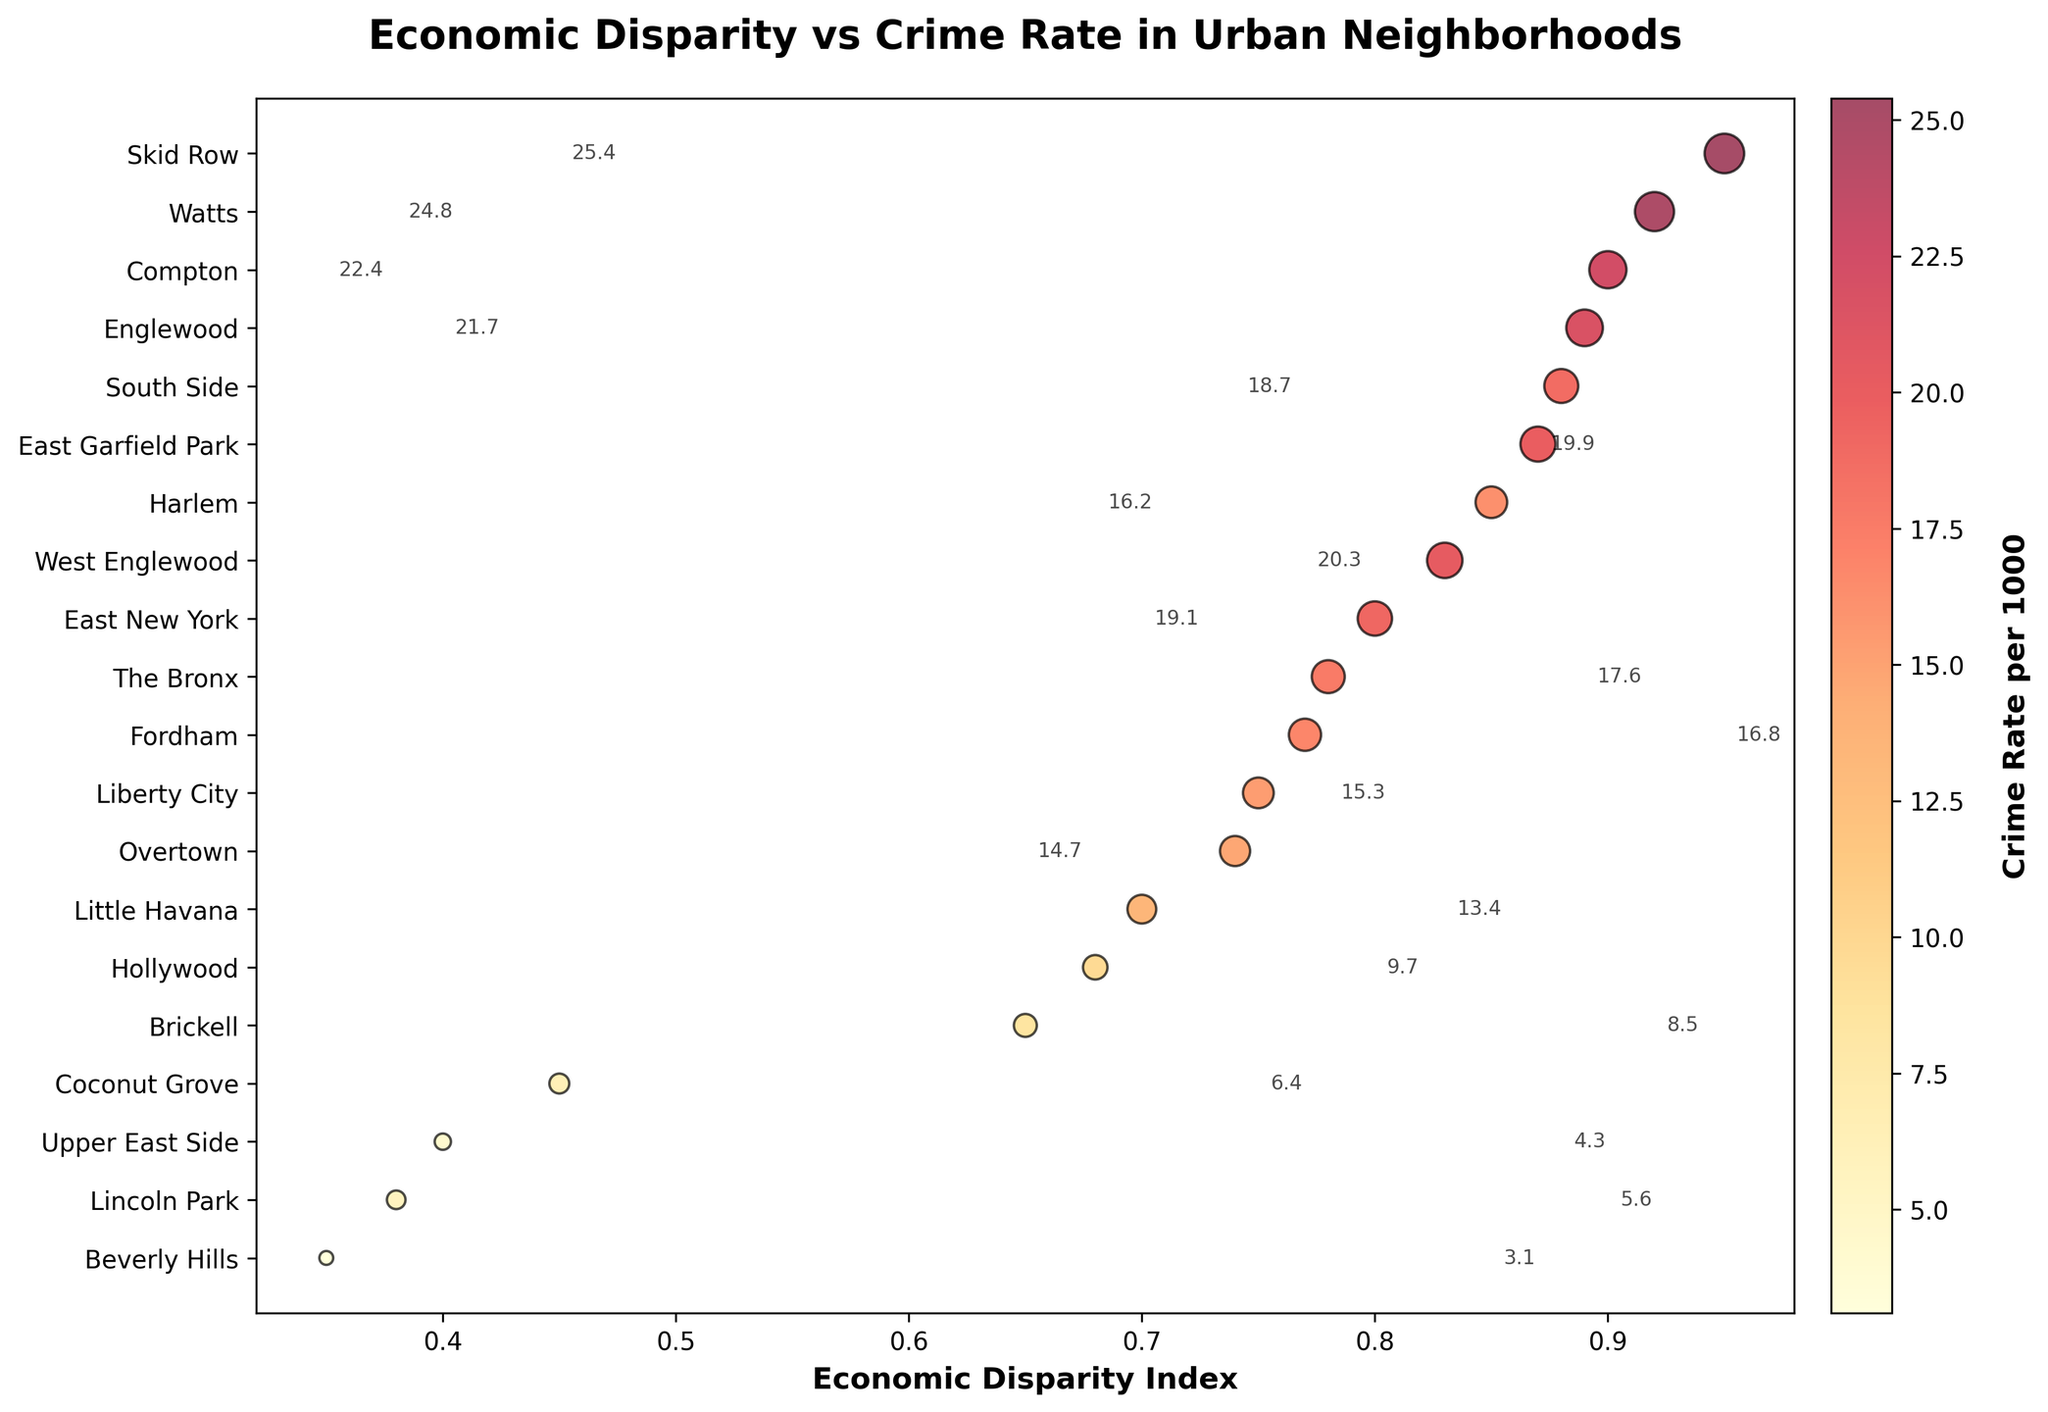What is the title of the plot? The title of the plot is displayed at the top of the figure. It reads "Economic Disparity vs Crime Rate in Urban Neighborhoods".
Answer: Economic Disparity vs Crime Rate in Urban Neighborhoods Which neighborhood has the highest economic disparity index? Look at the x-axis representing the Economic Disparity Index and find the neighborhood farthest to the right. This is Skid Row (Los Angeles).
Answer: Skid Row (Los Angeles) How many neighborhoods are shown in this plot? Each dot represents a neighborhood. Counting up the dots or the y-axis labels gives the total number.
Answer: 20 Which neighborhood has the lowest crime rate? Find the smallest dot size with a color representing a low crime rate (near the bottom edge of the color bar) and check the neighborhood label. It is Beverly Hills (Los Angeles).
Answer: Beverly Hills (Los Angeles) Compare the crime rates between Skid Row (Los Angeles) and Upper East Side (New York City). Which is lower? Skid Row has a larger dot size and darker color indicating a higher crime rate, whereas Upper East Side has a very small dot, indicating a lower crime rate.
Answer: Upper East Side (New York City) What is the general trend between economic disparity and crime rate? Observing the plot, neighborhoods with higher Economic Disparity Index generally have larger dots and darker colors, indicating higher crime rates. This suggests a positive correlation.
Answer: Higher economic disparity tends to correlate with higher crime rates Which city has the neighborhood with the highest crime rate, and what is it? Locate the neighborhood with the largest dot and darkest color. This is Skid Row (Los Angeles) with a crime rate of 25.4 per 1000.
Answer: Skid Row (Los Angeles) What is the average crime rate of the neighborhoods in Miami? Identify Miami neighborhoods: Liberty City (15.3), Brickell (8.5), Little Havana (13.4), Overtown (14.7), and Coconut Grove (6.4). Sum these crime rates (15.3 + 8.5 + 13.4 + 14.7 + 6.4) and divide by the number of neighborhoods (5). The average is approximately 11.66.
Answer: 11.66 Which neighborhoods have an Economic Disparity Index less than 0.50? Identify neighborhoods within the left half of the x-axis and look at their labels: Upper East Side (New York City), Beverly Hills (Los Angeles), Lincoln Park (Chicago), and Coconut Grove (Miami).
Answer: Upper East Side (New York City), Beverly Hills (Los Angeles), Lincoln Park (Chicago), Coconut Grove (Miami) What is the crime rate difference between Fordham (New York City) and Hollywood (Los Angeles)? Identify the crime rates of Fordham (16.8) and Hollywood (9.7). Subtract the smaller value from the larger one: 16.8 - 9.7 = 7.1.
Answer: 7.1 